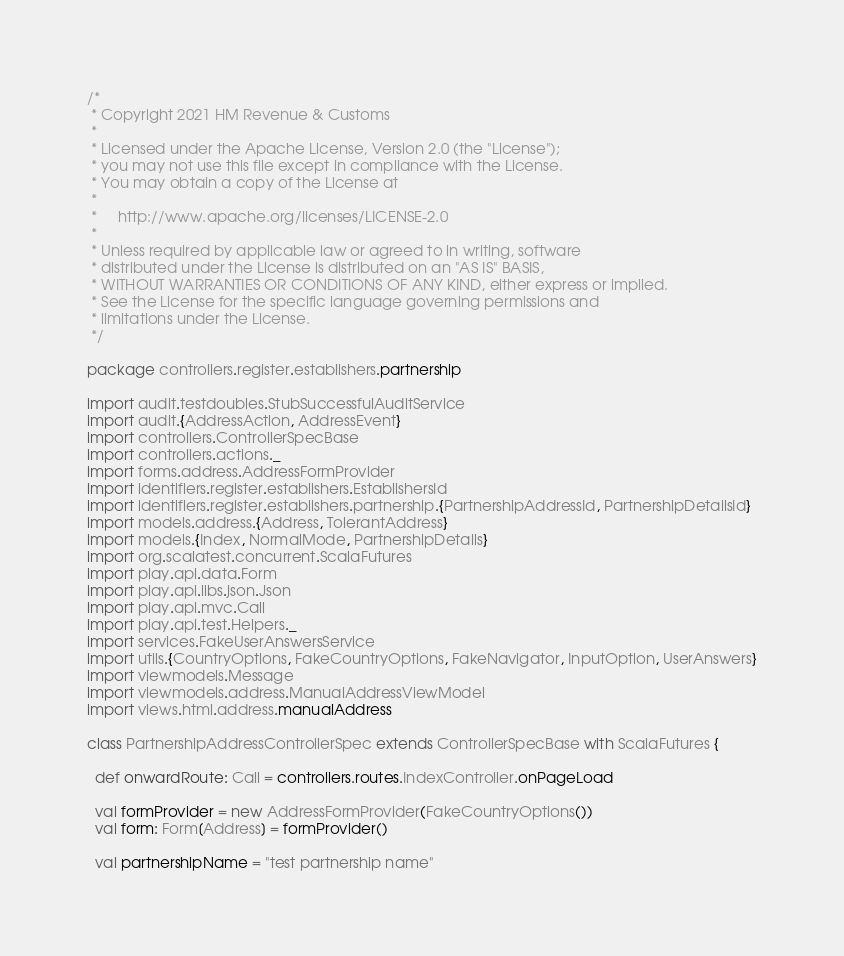Convert code to text. <code><loc_0><loc_0><loc_500><loc_500><_Scala_>/*
 * Copyright 2021 HM Revenue & Customs
 *
 * Licensed under the Apache License, Version 2.0 (the "License");
 * you may not use this file except in compliance with the License.
 * You may obtain a copy of the License at
 *
 *     http://www.apache.org/licenses/LICENSE-2.0
 *
 * Unless required by applicable law or agreed to in writing, software
 * distributed under the License is distributed on an "AS IS" BASIS,
 * WITHOUT WARRANTIES OR CONDITIONS OF ANY KIND, either express or implied.
 * See the License for the specific language governing permissions and
 * limitations under the License.
 */

package controllers.register.establishers.partnership

import audit.testdoubles.StubSuccessfulAuditService
import audit.{AddressAction, AddressEvent}
import controllers.ControllerSpecBase
import controllers.actions._
import forms.address.AddressFormProvider
import identifiers.register.establishers.EstablishersId
import identifiers.register.establishers.partnership.{PartnershipAddressId, PartnershipDetailsId}
import models.address.{Address, TolerantAddress}
import models.{Index, NormalMode, PartnershipDetails}
import org.scalatest.concurrent.ScalaFutures
import play.api.data.Form
import play.api.libs.json.Json
import play.api.mvc.Call
import play.api.test.Helpers._
import services.FakeUserAnswersService
import utils.{CountryOptions, FakeCountryOptions, FakeNavigator, InputOption, UserAnswers}
import viewmodels.Message
import viewmodels.address.ManualAddressViewModel
import views.html.address.manualAddress

class PartnershipAddressControllerSpec extends ControllerSpecBase with ScalaFutures {

  def onwardRoute: Call = controllers.routes.IndexController.onPageLoad

  val formProvider = new AddressFormProvider(FakeCountryOptions())
  val form: Form[Address] = formProvider()

  val partnershipName = "test partnership name"</code> 